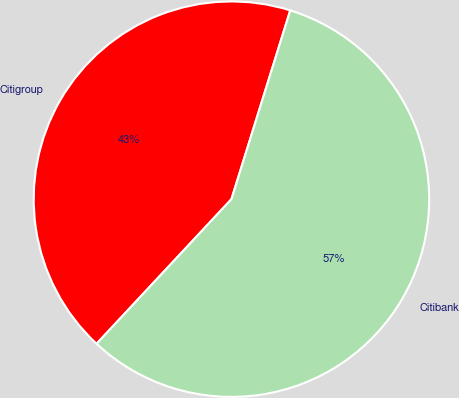<chart> <loc_0><loc_0><loc_500><loc_500><pie_chart><fcel>Citigroup<fcel>Citibank<nl><fcel>42.86%<fcel>57.14%<nl></chart> 